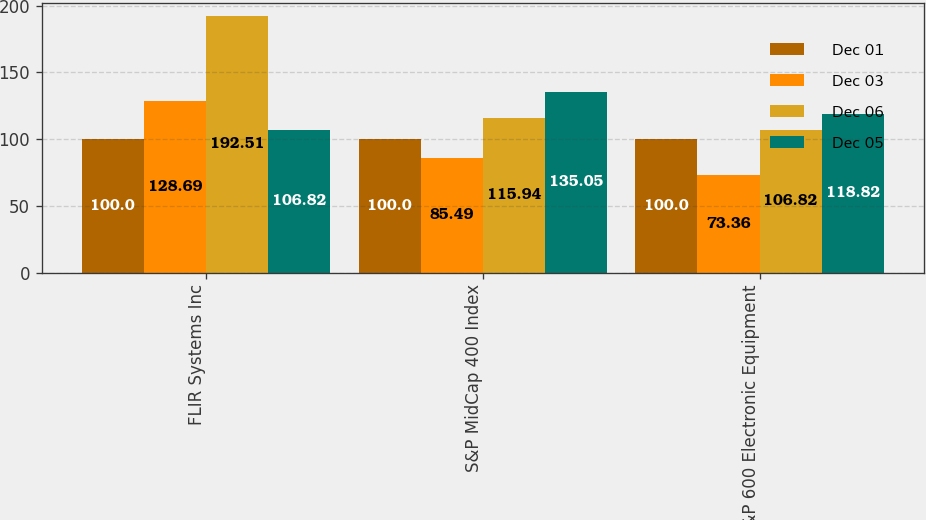Convert chart to OTSL. <chart><loc_0><loc_0><loc_500><loc_500><stacked_bar_chart><ecel><fcel>FLIR Systems Inc<fcel>S&P MidCap 400 Index<fcel>S&P 600 Electronic Equipment<nl><fcel>Dec 01<fcel>100<fcel>100<fcel>100<nl><fcel>Dec 03<fcel>128.69<fcel>85.49<fcel>73.36<nl><fcel>Dec 06<fcel>192.51<fcel>115.94<fcel>106.82<nl><fcel>Dec 05<fcel>106.82<fcel>135.05<fcel>118.82<nl></chart> 